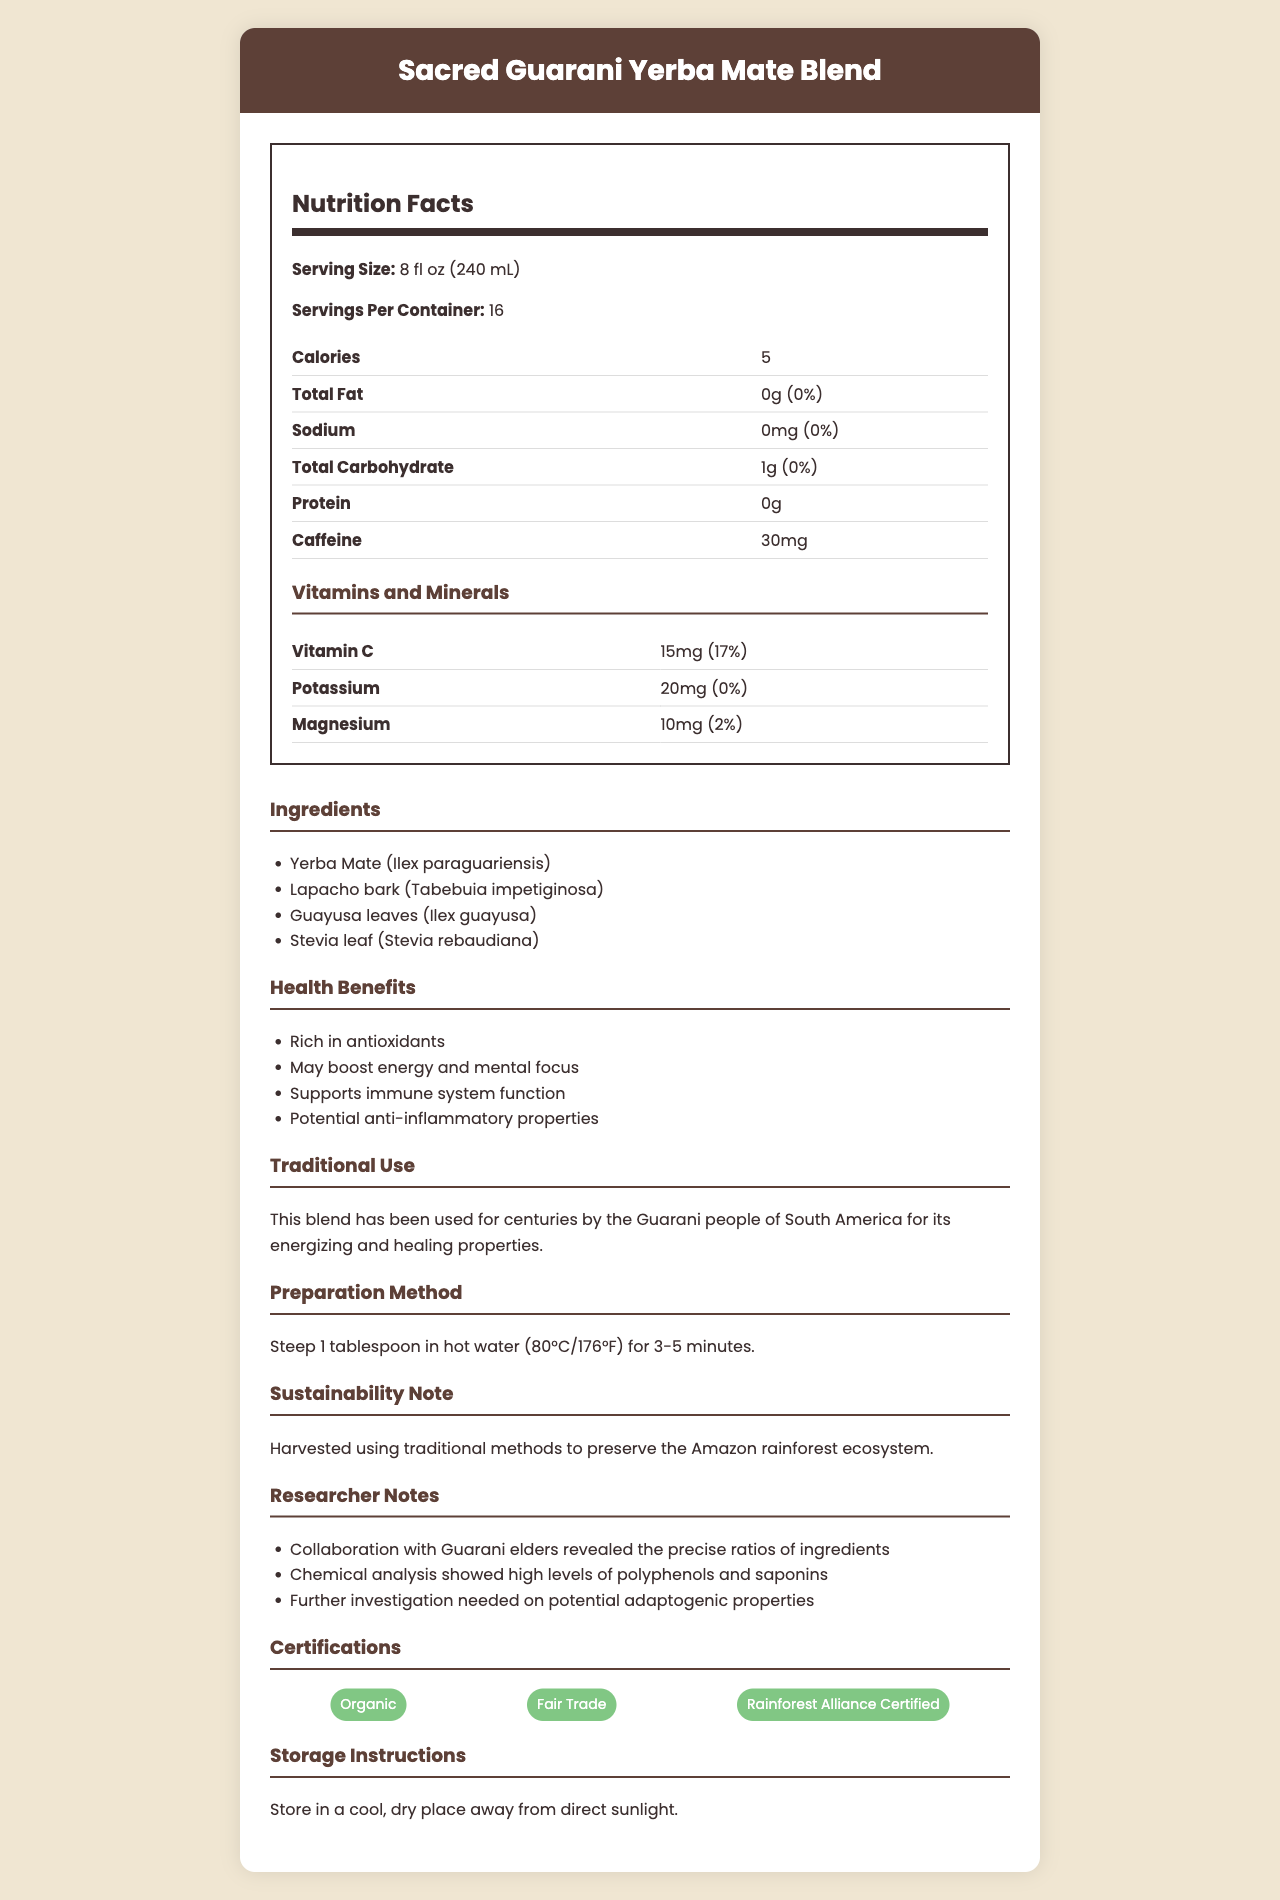What is the serving size for Sacred Guarani Yerba Mate Blend? The serving size is clearly listed as 8 fl oz (240 mL) in the document.
Answer: 8 fl oz (240 mL) How many servings are there per container? The document specifies that there are 16 servings per container.
Answer: 16 How many calories are there per serving? The document lists the calories per serving as 5.
Answer: 5 Which vitamin is present in the highest amount per serving? The document lists Vitamin C as having 15mg per serving, the highest among the vitamins and minerals listed.
Answer: Vitamin C What is the caffeine content in each serving? The document specifies that each serving contains 30mg of caffeine.
Answer: 30mg What are the main ingredients in the Sacred Guarani Yerba Mate Blend? A. Yerba Mate, Lapacho bark, Guayusa, Stevia B. Green tea, Lemon, Honey C. Chamomile, Lavender, Peppermint The ingredients listed in the document include Yerba Mate, Lapacho bark, Guayusa leaves, and Stevia leaf.
Answer: A. Yerba Mate, Lapacho bark, Guayusa, Stevia Which of the following certifications does the product have? I. Organic II. Fair Trade III. Non-GMO The document lists the certifications as Organic, Fair Trade, and Rainforest Alliance Certified, and does not mention Non-GMO.
Answer: I and II Is the total fat content in Sacred Guarani Yerba Mate Blend high? The document lists the total fat content as 0g, which is 0% of the daily value, indicating it is not high.
Answer: No Summarize the main idea of this document. The document aims to give a comprehensive overview of the product's nutritional content, health benefits, cultural background, and preparation tips, while also highlighting its sustainable and ethical sourcing.
Answer: The document provides detailed information about the Sacred Guarani Yerba Mate Blend, including nutritional facts, ingredients, health benefits, traditional use, preparation method, sustainability note, researcher notes, certifications, and storage instructions. What were the specific polyphenols and saponins levels found in the chemical analysis? The document mentions chemical analysis revealed high levels of polyphenols and saponins, but does not provide specific details.
Answer: Cannot be determined 